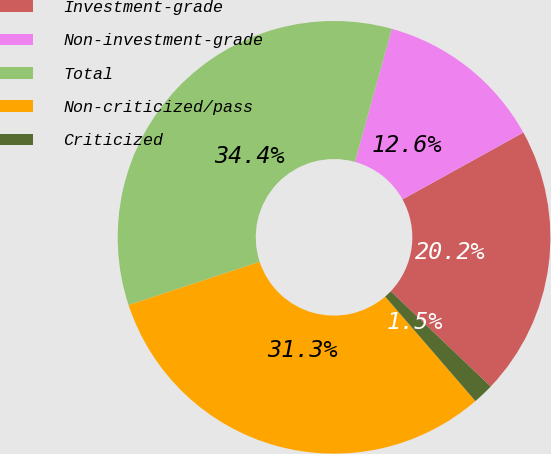Convert chart. <chart><loc_0><loc_0><loc_500><loc_500><pie_chart><fcel>Investment-grade<fcel>Non-investment-grade<fcel>Total<fcel>Non-criticized/pass<fcel>Criticized<nl><fcel>20.16%<fcel>12.65%<fcel>34.38%<fcel>31.26%<fcel>1.55%<nl></chart> 